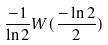<formula> <loc_0><loc_0><loc_500><loc_500>\frac { - 1 } { \ln 2 } W ( \frac { - \ln 2 } { 2 } )</formula> 